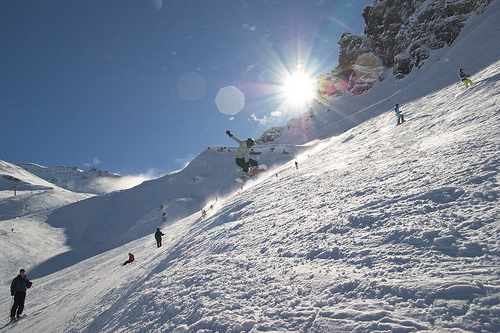What kind of activity is taking place in this image? The image depicts a lively winter sports scene, likely at a ski resort, where individuals are snowboarding and skiing down snowy slopes under the radiant sun. Can you tell me about the environment where they are performing these activities? Certainly, the environment is characterized by thick blankets of snow covering rolling hills with the presence of rocky outcrops. The sun is shining brightly in the blue sky, indicating favorable weather conditions for snow sports. 